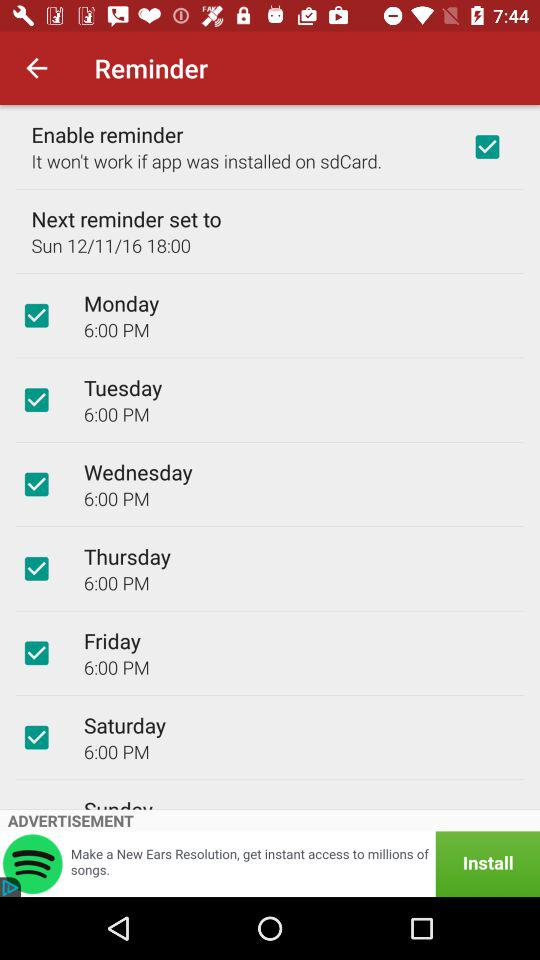At what time is the "Next reminder set to"? The time is 6:00 PM. 